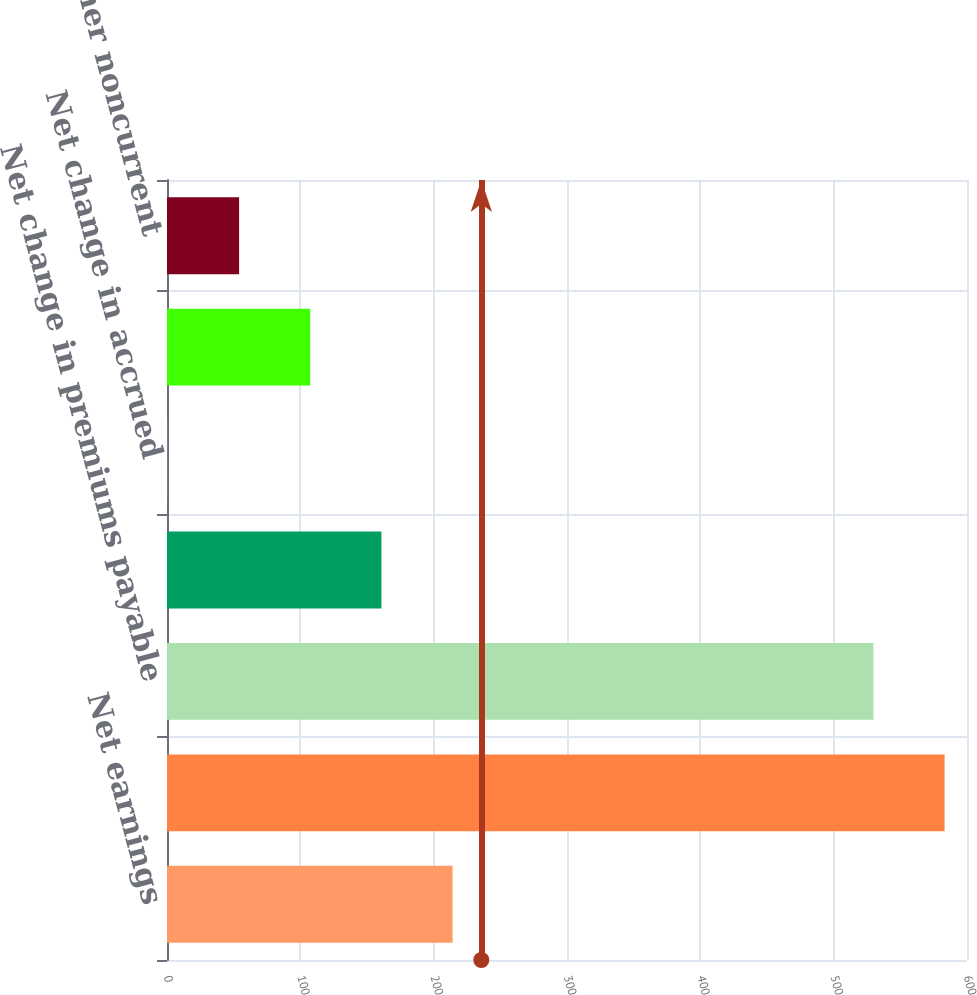<chart> <loc_0><loc_0><loc_500><loc_500><bar_chart><fcel>Net earnings<fcel>Net change in premiums and<fcel>Net change in premiums payable<fcel>Net change in other current<fcel>Net change in accrued<fcel>Net change in deferred income<fcel>Net change in other noncurrent<nl><fcel>214.18<fcel>583.17<fcel>529.8<fcel>160.81<fcel>0.7<fcel>107.44<fcel>54.07<nl></chart> 